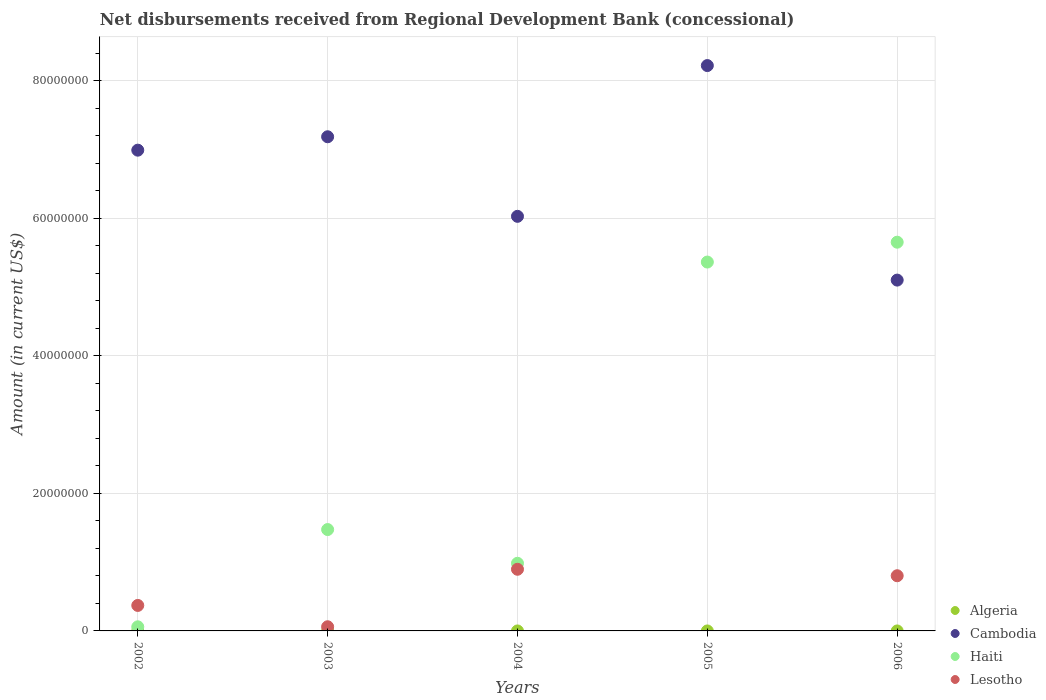How many different coloured dotlines are there?
Give a very brief answer. 3. What is the amount of disbursements received from Regional Development Bank in Lesotho in 2002?
Ensure brevity in your answer.  3.70e+06. Across all years, what is the maximum amount of disbursements received from Regional Development Bank in Cambodia?
Your response must be concise. 8.22e+07. Across all years, what is the minimum amount of disbursements received from Regional Development Bank in Algeria?
Keep it short and to the point. 0. What is the total amount of disbursements received from Regional Development Bank in Haiti in the graph?
Provide a short and direct response. 1.35e+08. What is the difference between the amount of disbursements received from Regional Development Bank in Haiti in 2003 and that in 2004?
Your response must be concise. 4.90e+06. What is the difference between the amount of disbursements received from Regional Development Bank in Lesotho in 2004 and the amount of disbursements received from Regional Development Bank in Cambodia in 2003?
Offer a terse response. -6.29e+07. What is the average amount of disbursements received from Regional Development Bank in Haiti per year?
Your answer should be compact. 2.71e+07. In the year 2006, what is the difference between the amount of disbursements received from Regional Development Bank in Cambodia and amount of disbursements received from Regional Development Bank in Lesotho?
Provide a succinct answer. 4.30e+07. In how many years, is the amount of disbursements received from Regional Development Bank in Haiti greater than 68000000 US$?
Give a very brief answer. 0. What is the ratio of the amount of disbursements received from Regional Development Bank in Lesotho in 2004 to that in 2006?
Offer a terse response. 1.12. Is the amount of disbursements received from Regional Development Bank in Haiti in 2002 less than that in 2004?
Offer a very short reply. Yes. What is the difference between the highest and the second highest amount of disbursements received from Regional Development Bank in Cambodia?
Your answer should be compact. 1.04e+07. What is the difference between the highest and the lowest amount of disbursements received from Regional Development Bank in Haiti?
Your response must be concise. 5.59e+07. Is it the case that in every year, the sum of the amount of disbursements received from Regional Development Bank in Lesotho and amount of disbursements received from Regional Development Bank in Algeria  is greater than the sum of amount of disbursements received from Regional Development Bank in Haiti and amount of disbursements received from Regional Development Bank in Cambodia?
Ensure brevity in your answer.  No. Is it the case that in every year, the sum of the amount of disbursements received from Regional Development Bank in Haiti and amount of disbursements received from Regional Development Bank in Cambodia  is greater than the amount of disbursements received from Regional Development Bank in Algeria?
Your answer should be compact. Yes. Does the amount of disbursements received from Regional Development Bank in Algeria monotonically increase over the years?
Your answer should be compact. No. How many dotlines are there?
Keep it short and to the point. 3. How many years are there in the graph?
Offer a terse response. 5. What is the difference between two consecutive major ticks on the Y-axis?
Your answer should be compact. 2.00e+07. Are the values on the major ticks of Y-axis written in scientific E-notation?
Your response must be concise. No. Does the graph contain grids?
Your answer should be very brief. Yes. Where does the legend appear in the graph?
Your answer should be very brief. Bottom right. How many legend labels are there?
Provide a succinct answer. 4. How are the legend labels stacked?
Your answer should be compact. Vertical. What is the title of the graph?
Offer a very short reply. Net disbursements received from Regional Development Bank (concessional). Does "Australia" appear as one of the legend labels in the graph?
Provide a succinct answer. No. What is the Amount (in current US$) of Algeria in 2002?
Give a very brief answer. 0. What is the Amount (in current US$) in Cambodia in 2002?
Offer a terse response. 6.99e+07. What is the Amount (in current US$) in Haiti in 2002?
Provide a short and direct response. 5.96e+05. What is the Amount (in current US$) of Lesotho in 2002?
Your answer should be compact. 3.70e+06. What is the Amount (in current US$) of Cambodia in 2003?
Ensure brevity in your answer.  7.18e+07. What is the Amount (in current US$) of Haiti in 2003?
Provide a short and direct response. 1.47e+07. What is the Amount (in current US$) in Lesotho in 2003?
Your response must be concise. 6.05e+05. What is the Amount (in current US$) in Algeria in 2004?
Keep it short and to the point. 0. What is the Amount (in current US$) in Cambodia in 2004?
Provide a short and direct response. 6.03e+07. What is the Amount (in current US$) of Haiti in 2004?
Your answer should be very brief. 9.84e+06. What is the Amount (in current US$) in Lesotho in 2004?
Give a very brief answer. 8.96e+06. What is the Amount (in current US$) in Algeria in 2005?
Provide a short and direct response. 0. What is the Amount (in current US$) of Cambodia in 2005?
Provide a succinct answer. 8.22e+07. What is the Amount (in current US$) in Haiti in 2005?
Offer a very short reply. 5.36e+07. What is the Amount (in current US$) in Lesotho in 2005?
Make the answer very short. 0. What is the Amount (in current US$) in Cambodia in 2006?
Your response must be concise. 5.10e+07. What is the Amount (in current US$) in Haiti in 2006?
Keep it short and to the point. 5.65e+07. What is the Amount (in current US$) in Lesotho in 2006?
Keep it short and to the point. 8.02e+06. Across all years, what is the maximum Amount (in current US$) of Cambodia?
Give a very brief answer. 8.22e+07. Across all years, what is the maximum Amount (in current US$) of Haiti?
Provide a short and direct response. 5.65e+07. Across all years, what is the maximum Amount (in current US$) in Lesotho?
Your response must be concise. 8.96e+06. Across all years, what is the minimum Amount (in current US$) of Cambodia?
Offer a very short reply. 5.10e+07. Across all years, what is the minimum Amount (in current US$) in Haiti?
Make the answer very short. 5.96e+05. Across all years, what is the minimum Amount (in current US$) in Lesotho?
Provide a short and direct response. 0. What is the total Amount (in current US$) of Cambodia in the graph?
Provide a short and direct response. 3.35e+08. What is the total Amount (in current US$) in Haiti in the graph?
Offer a very short reply. 1.35e+08. What is the total Amount (in current US$) in Lesotho in the graph?
Provide a succinct answer. 2.13e+07. What is the difference between the Amount (in current US$) in Cambodia in 2002 and that in 2003?
Your answer should be compact. -1.95e+06. What is the difference between the Amount (in current US$) of Haiti in 2002 and that in 2003?
Make the answer very short. -1.41e+07. What is the difference between the Amount (in current US$) of Lesotho in 2002 and that in 2003?
Make the answer very short. 3.10e+06. What is the difference between the Amount (in current US$) of Cambodia in 2002 and that in 2004?
Offer a terse response. 9.62e+06. What is the difference between the Amount (in current US$) in Haiti in 2002 and that in 2004?
Your answer should be very brief. -9.24e+06. What is the difference between the Amount (in current US$) of Lesotho in 2002 and that in 2004?
Offer a very short reply. -5.26e+06. What is the difference between the Amount (in current US$) in Cambodia in 2002 and that in 2005?
Make the answer very short. -1.23e+07. What is the difference between the Amount (in current US$) of Haiti in 2002 and that in 2005?
Provide a short and direct response. -5.30e+07. What is the difference between the Amount (in current US$) in Cambodia in 2002 and that in 2006?
Give a very brief answer. 1.89e+07. What is the difference between the Amount (in current US$) of Haiti in 2002 and that in 2006?
Your answer should be compact. -5.59e+07. What is the difference between the Amount (in current US$) in Lesotho in 2002 and that in 2006?
Provide a short and direct response. -4.32e+06. What is the difference between the Amount (in current US$) in Cambodia in 2003 and that in 2004?
Ensure brevity in your answer.  1.16e+07. What is the difference between the Amount (in current US$) in Haiti in 2003 and that in 2004?
Your answer should be compact. 4.90e+06. What is the difference between the Amount (in current US$) in Lesotho in 2003 and that in 2004?
Ensure brevity in your answer.  -8.36e+06. What is the difference between the Amount (in current US$) of Cambodia in 2003 and that in 2005?
Offer a very short reply. -1.04e+07. What is the difference between the Amount (in current US$) of Haiti in 2003 and that in 2005?
Offer a terse response. -3.89e+07. What is the difference between the Amount (in current US$) of Cambodia in 2003 and that in 2006?
Offer a terse response. 2.08e+07. What is the difference between the Amount (in current US$) of Haiti in 2003 and that in 2006?
Keep it short and to the point. -4.18e+07. What is the difference between the Amount (in current US$) in Lesotho in 2003 and that in 2006?
Your answer should be very brief. -7.42e+06. What is the difference between the Amount (in current US$) of Cambodia in 2004 and that in 2005?
Give a very brief answer. -2.19e+07. What is the difference between the Amount (in current US$) of Haiti in 2004 and that in 2005?
Provide a succinct answer. -4.38e+07. What is the difference between the Amount (in current US$) in Cambodia in 2004 and that in 2006?
Offer a very short reply. 9.27e+06. What is the difference between the Amount (in current US$) of Haiti in 2004 and that in 2006?
Keep it short and to the point. -4.67e+07. What is the difference between the Amount (in current US$) in Lesotho in 2004 and that in 2006?
Offer a very short reply. 9.41e+05. What is the difference between the Amount (in current US$) of Cambodia in 2005 and that in 2006?
Make the answer very short. 3.12e+07. What is the difference between the Amount (in current US$) of Haiti in 2005 and that in 2006?
Offer a very short reply. -2.89e+06. What is the difference between the Amount (in current US$) in Cambodia in 2002 and the Amount (in current US$) in Haiti in 2003?
Offer a terse response. 5.52e+07. What is the difference between the Amount (in current US$) in Cambodia in 2002 and the Amount (in current US$) in Lesotho in 2003?
Make the answer very short. 6.93e+07. What is the difference between the Amount (in current US$) of Haiti in 2002 and the Amount (in current US$) of Lesotho in 2003?
Provide a short and direct response. -9000. What is the difference between the Amount (in current US$) in Cambodia in 2002 and the Amount (in current US$) in Haiti in 2004?
Provide a short and direct response. 6.01e+07. What is the difference between the Amount (in current US$) of Cambodia in 2002 and the Amount (in current US$) of Lesotho in 2004?
Keep it short and to the point. 6.09e+07. What is the difference between the Amount (in current US$) of Haiti in 2002 and the Amount (in current US$) of Lesotho in 2004?
Make the answer very short. -8.37e+06. What is the difference between the Amount (in current US$) of Cambodia in 2002 and the Amount (in current US$) of Haiti in 2005?
Give a very brief answer. 1.63e+07. What is the difference between the Amount (in current US$) of Cambodia in 2002 and the Amount (in current US$) of Haiti in 2006?
Give a very brief answer. 1.34e+07. What is the difference between the Amount (in current US$) of Cambodia in 2002 and the Amount (in current US$) of Lesotho in 2006?
Provide a succinct answer. 6.19e+07. What is the difference between the Amount (in current US$) in Haiti in 2002 and the Amount (in current US$) in Lesotho in 2006?
Your answer should be compact. -7.43e+06. What is the difference between the Amount (in current US$) of Cambodia in 2003 and the Amount (in current US$) of Haiti in 2004?
Make the answer very short. 6.20e+07. What is the difference between the Amount (in current US$) in Cambodia in 2003 and the Amount (in current US$) in Lesotho in 2004?
Keep it short and to the point. 6.29e+07. What is the difference between the Amount (in current US$) of Haiti in 2003 and the Amount (in current US$) of Lesotho in 2004?
Ensure brevity in your answer.  5.77e+06. What is the difference between the Amount (in current US$) in Cambodia in 2003 and the Amount (in current US$) in Haiti in 2005?
Provide a short and direct response. 1.82e+07. What is the difference between the Amount (in current US$) of Cambodia in 2003 and the Amount (in current US$) of Haiti in 2006?
Ensure brevity in your answer.  1.53e+07. What is the difference between the Amount (in current US$) in Cambodia in 2003 and the Amount (in current US$) in Lesotho in 2006?
Your answer should be very brief. 6.38e+07. What is the difference between the Amount (in current US$) of Haiti in 2003 and the Amount (in current US$) of Lesotho in 2006?
Your answer should be very brief. 6.72e+06. What is the difference between the Amount (in current US$) of Cambodia in 2004 and the Amount (in current US$) of Haiti in 2005?
Your response must be concise. 6.65e+06. What is the difference between the Amount (in current US$) in Cambodia in 2004 and the Amount (in current US$) in Haiti in 2006?
Give a very brief answer. 3.76e+06. What is the difference between the Amount (in current US$) of Cambodia in 2004 and the Amount (in current US$) of Lesotho in 2006?
Make the answer very short. 5.23e+07. What is the difference between the Amount (in current US$) in Haiti in 2004 and the Amount (in current US$) in Lesotho in 2006?
Provide a short and direct response. 1.81e+06. What is the difference between the Amount (in current US$) in Cambodia in 2005 and the Amount (in current US$) in Haiti in 2006?
Provide a succinct answer. 2.57e+07. What is the difference between the Amount (in current US$) of Cambodia in 2005 and the Amount (in current US$) of Lesotho in 2006?
Your response must be concise. 7.42e+07. What is the difference between the Amount (in current US$) of Haiti in 2005 and the Amount (in current US$) of Lesotho in 2006?
Your response must be concise. 4.56e+07. What is the average Amount (in current US$) of Cambodia per year?
Provide a short and direct response. 6.70e+07. What is the average Amount (in current US$) of Haiti per year?
Ensure brevity in your answer.  2.71e+07. What is the average Amount (in current US$) in Lesotho per year?
Keep it short and to the point. 4.26e+06. In the year 2002, what is the difference between the Amount (in current US$) of Cambodia and Amount (in current US$) of Haiti?
Offer a very short reply. 6.93e+07. In the year 2002, what is the difference between the Amount (in current US$) of Cambodia and Amount (in current US$) of Lesotho?
Give a very brief answer. 6.62e+07. In the year 2002, what is the difference between the Amount (in current US$) of Haiti and Amount (in current US$) of Lesotho?
Ensure brevity in your answer.  -3.11e+06. In the year 2003, what is the difference between the Amount (in current US$) of Cambodia and Amount (in current US$) of Haiti?
Offer a terse response. 5.71e+07. In the year 2003, what is the difference between the Amount (in current US$) in Cambodia and Amount (in current US$) in Lesotho?
Offer a very short reply. 7.12e+07. In the year 2003, what is the difference between the Amount (in current US$) in Haiti and Amount (in current US$) in Lesotho?
Keep it short and to the point. 1.41e+07. In the year 2004, what is the difference between the Amount (in current US$) of Cambodia and Amount (in current US$) of Haiti?
Give a very brief answer. 5.04e+07. In the year 2004, what is the difference between the Amount (in current US$) of Cambodia and Amount (in current US$) of Lesotho?
Give a very brief answer. 5.13e+07. In the year 2004, what is the difference between the Amount (in current US$) in Haiti and Amount (in current US$) in Lesotho?
Make the answer very short. 8.71e+05. In the year 2005, what is the difference between the Amount (in current US$) in Cambodia and Amount (in current US$) in Haiti?
Make the answer very short. 2.86e+07. In the year 2006, what is the difference between the Amount (in current US$) of Cambodia and Amount (in current US$) of Haiti?
Your answer should be very brief. -5.51e+06. In the year 2006, what is the difference between the Amount (in current US$) in Cambodia and Amount (in current US$) in Lesotho?
Provide a short and direct response. 4.30e+07. In the year 2006, what is the difference between the Amount (in current US$) of Haiti and Amount (in current US$) of Lesotho?
Offer a very short reply. 4.85e+07. What is the ratio of the Amount (in current US$) in Cambodia in 2002 to that in 2003?
Provide a succinct answer. 0.97. What is the ratio of the Amount (in current US$) of Haiti in 2002 to that in 2003?
Your response must be concise. 0.04. What is the ratio of the Amount (in current US$) of Lesotho in 2002 to that in 2003?
Your answer should be very brief. 6.12. What is the ratio of the Amount (in current US$) in Cambodia in 2002 to that in 2004?
Offer a very short reply. 1.16. What is the ratio of the Amount (in current US$) in Haiti in 2002 to that in 2004?
Offer a terse response. 0.06. What is the ratio of the Amount (in current US$) of Lesotho in 2002 to that in 2004?
Your response must be concise. 0.41. What is the ratio of the Amount (in current US$) in Cambodia in 2002 to that in 2005?
Your answer should be very brief. 0.85. What is the ratio of the Amount (in current US$) of Haiti in 2002 to that in 2005?
Provide a succinct answer. 0.01. What is the ratio of the Amount (in current US$) of Cambodia in 2002 to that in 2006?
Your answer should be very brief. 1.37. What is the ratio of the Amount (in current US$) in Haiti in 2002 to that in 2006?
Ensure brevity in your answer.  0.01. What is the ratio of the Amount (in current US$) of Lesotho in 2002 to that in 2006?
Keep it short and to the point. 0.46. What is the ratio of the Amount (in current US$) in Cambodia in 2003 to that in 2004?
Give a very brief answer. 1.19. What is the ratio of the Amount (in current US$) of Haiti in 2003 to that in 2004?
Offer a terse response. 1.5. What is the ratio of the Amount (in current US$) in Lesotho in 2003 to that in 2004?
Provide a succinct answer. 0.07. What is the ratio of the Amount (in current US$) in Cambodia in 2003 to that in 2005?
Provide a succinct answer. 0.87. What is the ratio of the Amount (in current US$) of Haiti in 2003 to that in 2005?
Your answer should be very brief. 0.27. What is the ratio of the Amount (in current US$) in Cambodia in 2003 to that in 2006?
Provide a short and direct response. 1.41. What is the ratio of the Amount (in current US$) in Haiti in 2003 to that in 2006?
Ensure brevity in your answer.  0.26. What is the ratio of the Amount (in current US$) of Lesotho in 2003 to that in 2006?
Make the answer very short. 0.08. What is the ratio of the Amount (in current US$) of Cambodia in 2004 to that in 2005?
Your response must be concise. 0.73. What is the ratio of the Amount (in current US$) in Haiti in 2004 to that in 2005?
Offer a terse response. 0.18. What is the ratio of the Amount (in current US$) of Cambodia in 2004 to that in 2006?
Ensure brevity in your answer.  1.18. What is the ratio of the Amount (in current US$) in Haiti in 2004 to that in 2006?
Provide a succinct answer. 0.17. What is the ratio of the Amount (in current US$) of Lesotho in 2004 to that in 2006?
Your response must be concise. 1.12. What is the ratio of the Amount (in current US$) of Cambodia in 2005 to that in 2006?
Provide a short and direct response. 1.61. What is the ratio of the Amount (in current US$) of Haiti in 2005 to that in 2006?
Your answer should be compact. 0.95. What is the difference between the highest and the second highest Amount (in current US$) of Cambodia?
Your answer should be compact. 1.04e+07. What is the difference between the highest and the second highest Amount (in current US$) in Haiti?
Your response must be concise. 2.89e+06. What is the difference between the highest and the second highest Amount (in current US$) in Lesotho?
Provide a succinct answer. 9.41e+05. What is the difference between the highest and the lowest Amount (in current US$) of Cambodia?
Make the answer very short. 3.12e+07. What is the difference between the highest and the lowest Amount (in current US$) of Haiti?
Offer a very short reply. 5.59e+07. What is the difference between the highest and the lowest Amount (in current US$) in Lesotho?
Give a very brief answer. 8.96e+06. 